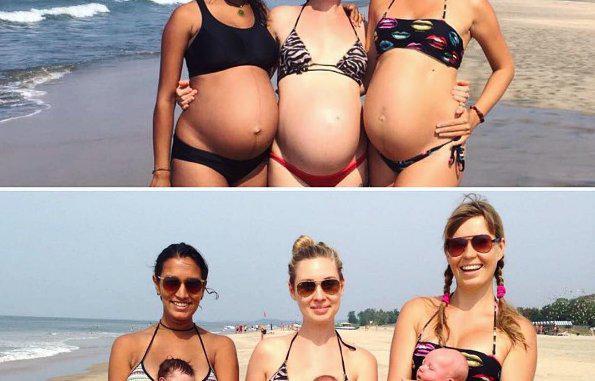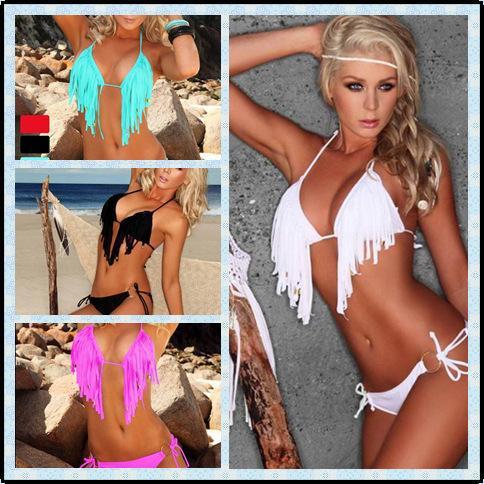The first image is the image on the left, the second image is the image on the right. Analyze the images presented: Is the assertion "At least one image depicts a trio of rear-facing arm-linked models in front of water." valid? Answer yes or no. No. 